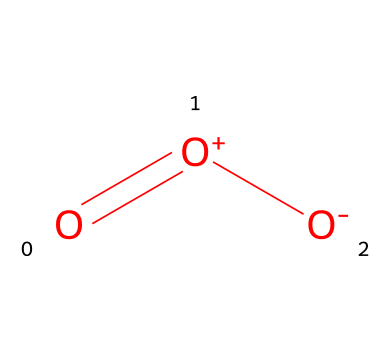How many oxygen atoms are present in this molecule? The SMILES representation indicates that there are three 'O' symbols, which correspond to three oxygen atoms in the structure.
Answer: three What type of bond is present between the atoms? In the SMILES notation, there is an '=' sign indicating a double bond between the first oxygen (O) and the second oxygen ([O+]), and a single bond between the second oxygen and the third oxygen ([O-]).
Answer: double and single What is the overall charge of the molecule? The notation [O+] indicates a positive charge on the second oxygen, and [O-] indicates a negative charge on the third oxygen. The molecule overall has a neutral charge because the positive and negative charges cancel each other out.
Answer: neutral Which arrangement leads to the molecule's instability? The presence of charges ([O+] and [O-]) contributes to the reactive nature of ozone, coupled with its bent molecular geometry due to the double bond, creates a scenario where ozone is less stable compared to molecular oxygen (O2).
Answer: bent geometry Is this molecule a gas at room temperature? Ozone is commonly known to exist as a gas in the Earth's stratosphere at typical atmospheric temperatures.
Answer: yes How does ozone contribute to the Earth's atmosphere? Ozone acts as a protective layer in the stratosphere by absorbing the majority of the sun's harmful ultraviolet radiation, which is crucial for life on Earth.
Answer: absorbs UV radiation 